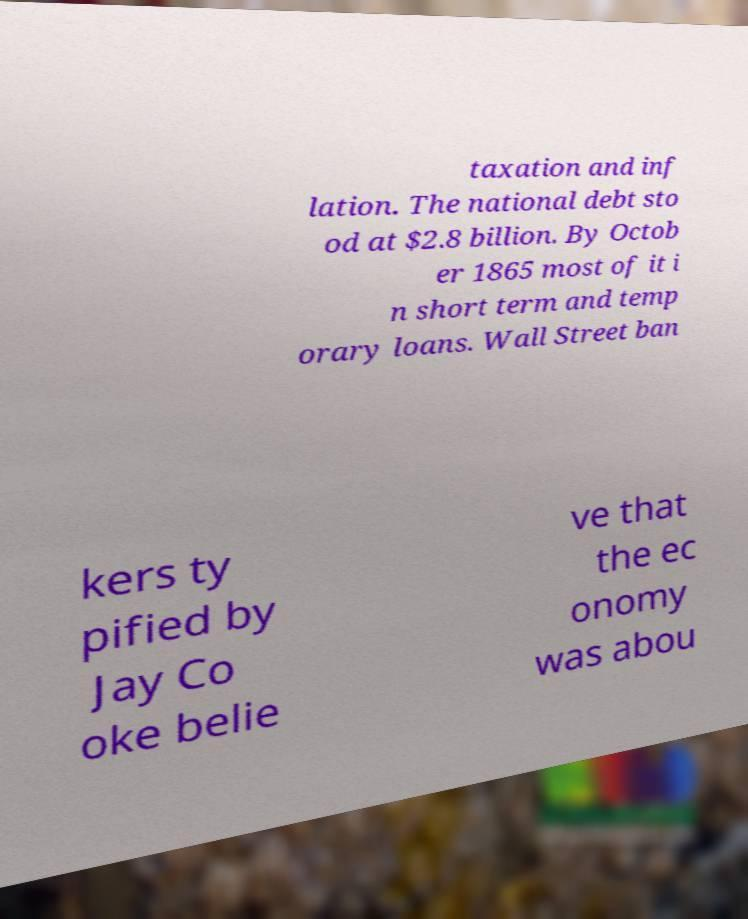I need the written content from this picture converted into text. Can you do that? taxation and inf lation. The national debt sto od at $2.8 billion. By Octob er 1865 most of it i n short term and temp orary loans. Wall Street ban kers ty pified by Jay Co oke belie ve that the ec onomy was abou 